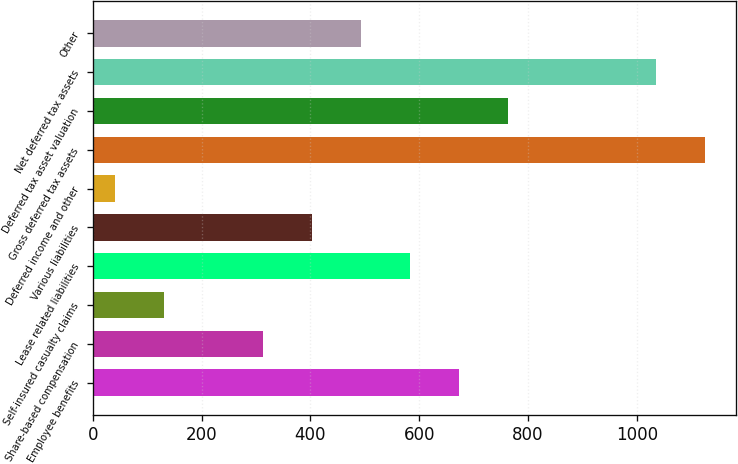Convert chart. <chart><loc_0><loc_0><loc_500><loc_500><bar_chart><fcel>Employee benefits<fcel>Share-based compensation<fcel>Self-insured casualty claims<fcel>Lease related liabilities<fcel>Various liabilities<fcel>Deferred income and other<fcel>Gross deferred tax assets<fcel>Deferred tax asset valuation<fcel>Net deferred tax assets<fcel>Other<nl><fcel>673.8<fcel>312.2<fcel>131.4<fcel>583.4<fcel>402.6<fcel>41<fcel>1125.8<fcel>764.2<fcel>1035.4<fcel>493<nl></chart> 